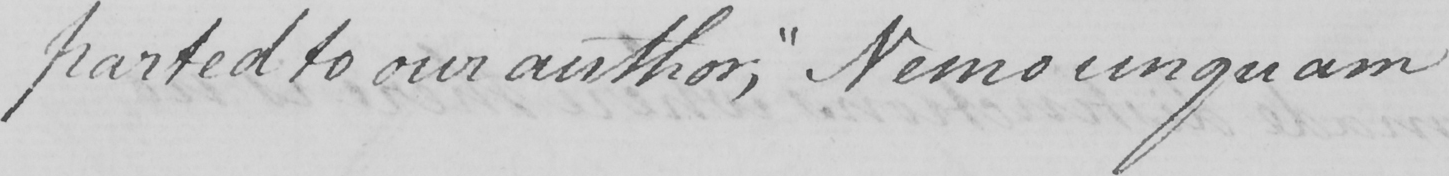Please provide the text content of this handwritten line. -parted to our author ,  " Nemo unquam 